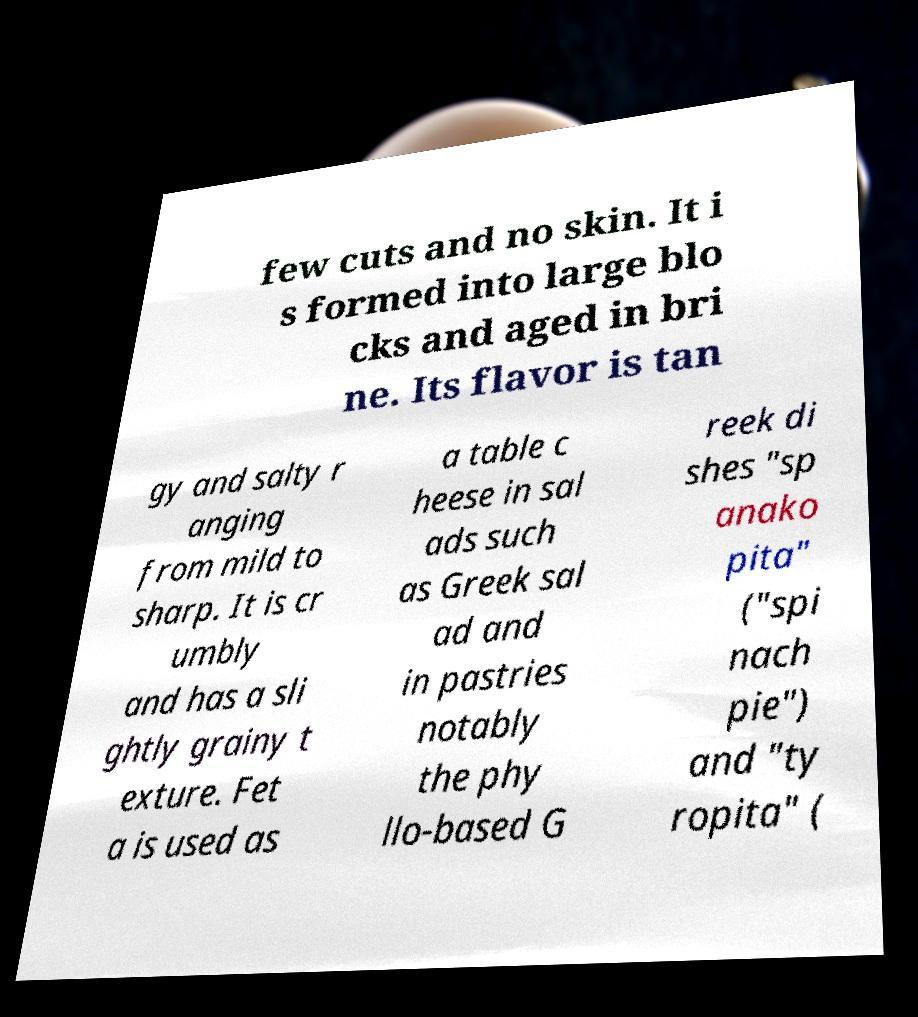Could you extract and type out the text from this image? few cuts and no skin. It i s formed into large blo cks and aged in bri ne. Its flavor is tan gy and salty r anging from mild to sharp. It is cr umbly and has a sli ghtly grainy t exture. Fet a is used as a table c heese in sal ads such as Greek sal ad and in pastries notably the phy llo-based G reek di shes "sp anako pita" ("spi nach pie") and "ty ropita" ( 